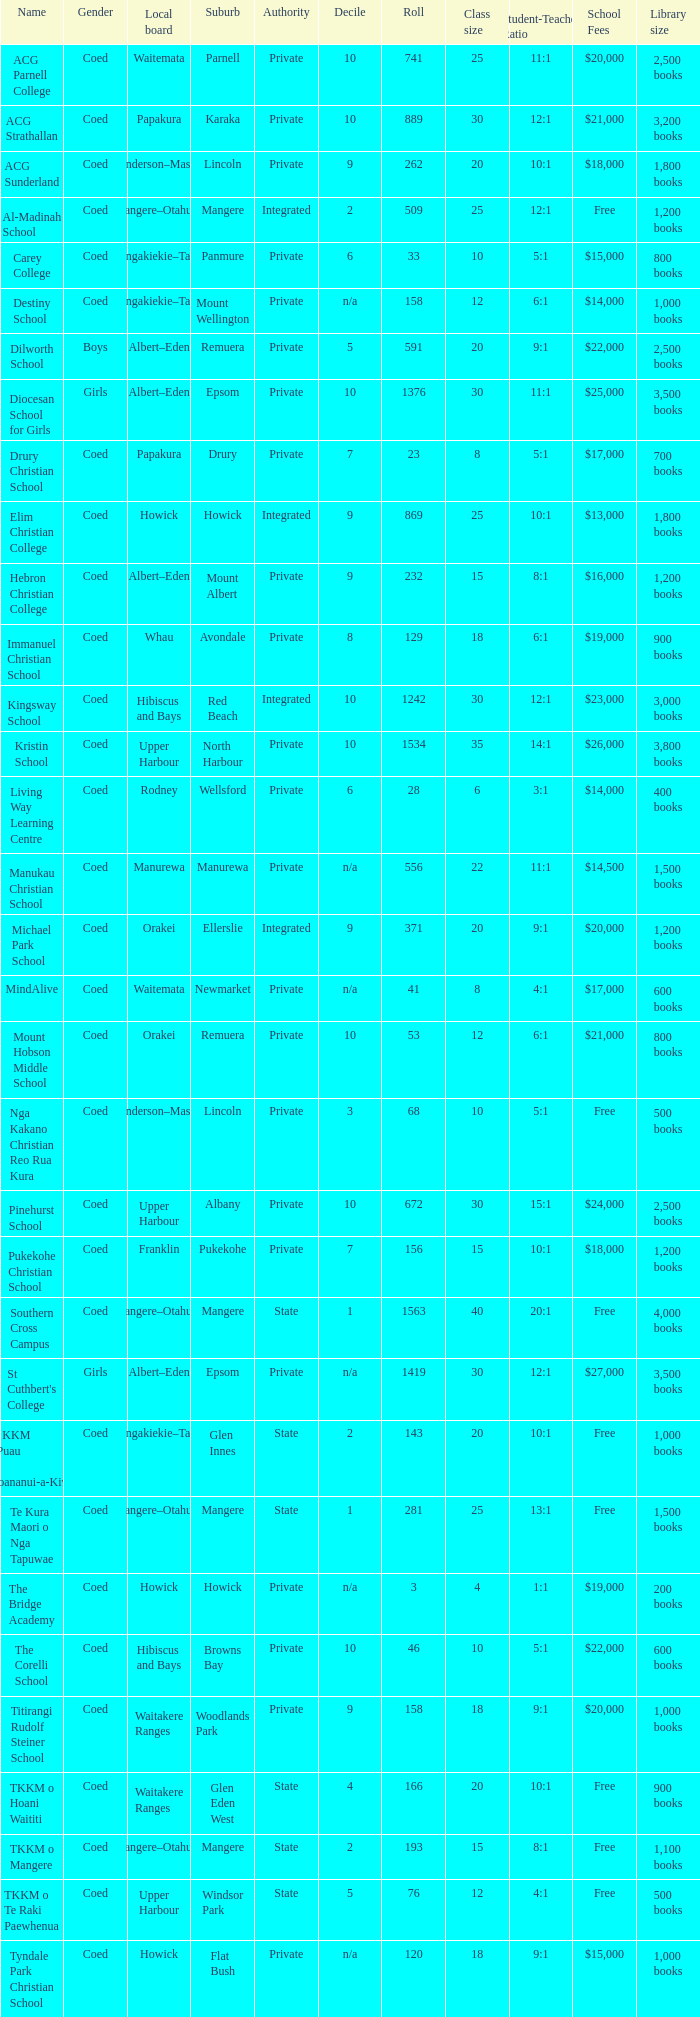What is the name of the suburb with a roll of 741? Parnell. 